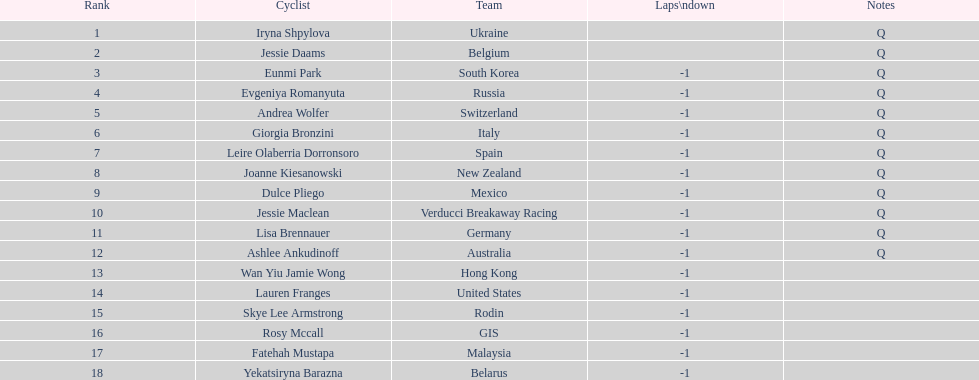Who was the opponent that concluded before jessie maclean? Dulce Pliego. 